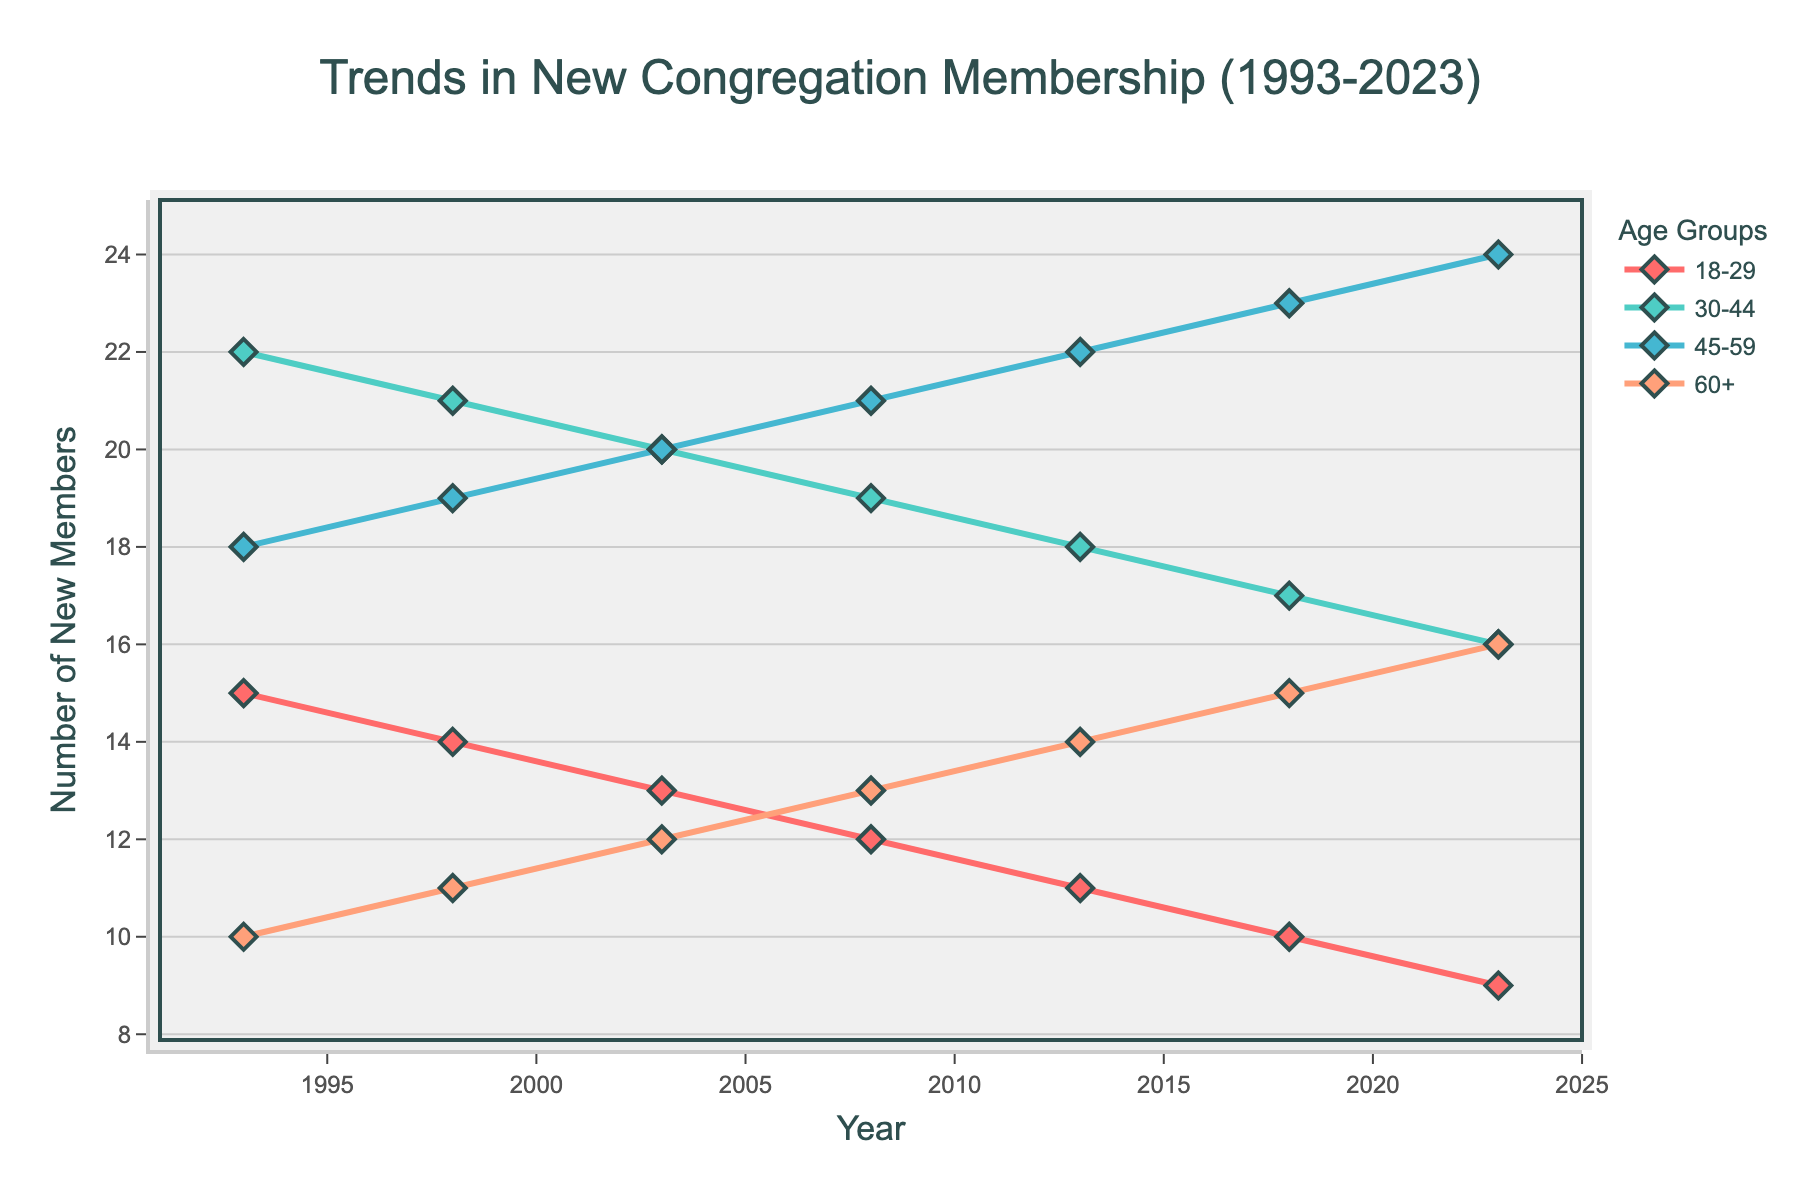What is the trend for new membership among the 60+ age group from 1993 to 2023? The trend for new membership among the 60+ age group shows a steady increase over the years. Starting from 10 in 1993, the number of new members rises gradually to 16 in 2023.
Answer: Steady increase Which age group had the highest increase in new membership from 1993 to 2023? To determine the highest increase, we calculate the difference between the values in 2023 and 1993 for each age group: 18-29 (9-15 = -6), 30-44 (16-22 = -6), 45-59 (24-18 = 6), 60+ (16-10 = 6). The 45-59 and 60+ age groups both show an increase of 6.
Answer: 45-59 and 60+ How does the membership trend for the 18-29 age group compare to the 45-59 age group over the years? The 18-29 age group shows a consistent decline in new membership from 1993 (15) to 2023 (9). In contrast, the 45-59 age group shows an opposite trend, increasing steadily from 1993 (18) to 2023 (24).
Answer: 18-29 declines, 45-59 increases What is the total number of new members across all age groups in 2023? To find the total new members in 2023, sum all the values for that year: 9 (18-29) + 16 (30-44) + 24 (45-59) + 16 (60+) = 65.
Answer: 65 Which age group consistently had the highest number of new members each year? Observing the plot, the 30-44 age group consistently had the highest number of new members each year until it was surpassed by the 45-59 age group starting around 2013.
Answer: 30-44 until 2013, then 45-59 Compare the trend lines of the 30-44 and 45-59 age groups from 1993 to 2023. The 30-44 age group shows a gradual decline in new membership from 22 in 1993 to 16 in 2023. Conversely, the 45-59 age group shows a constant increase from 18 in 1993 to 24 in 2023.
Answer: 30-44 declines, 45-59 increases Which age group exhibited the most stable trend from 1993 to 2023? The 60+ age group exhibited the most stable trend, showing a steady increase with minimal fluctuations, rising from 10 in 1993 to 16 in 2023.
Answer: 60+ 